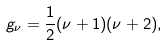Convert formula to latex. <formula><loc_0><loc_0><loc_500><loc_500>g _ { \nu } = \frac { 1 } { 2 } ( \nu + 1 ) ( \nu + 2 ) ,</formula> 